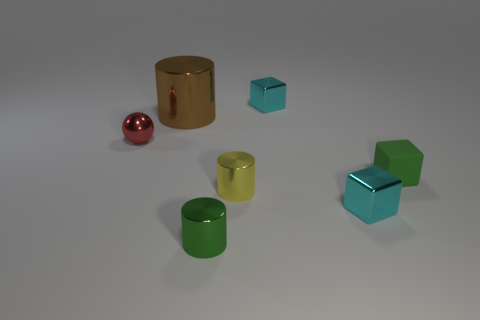Are there any other things that have the same material as the small green block?
Offer a terse response. No. Is there anything else that has the same size as the brown metallic object?
Offer a terse response. No. There is a matte object; does it have the same color as the small cylinder to the left of the tiny yellow cylinder?
Offer a very short reply. Yes. Are there an equal number of tiny yellow metal objects in front of the tiny green metallic cylinder and tiny spheres?
Give a very brief answer. No. What number of rubber blocks have the same size as the brown object?
Ensure brevity in your answer.  0. There is a thing that is the same color as the matte block; what shape is it?
Make the answer very short. Cylinder. Are any shiny cylinders visible?
Your answer should be compact. Yes. Do the brown thing behind the red thing and the cyan shiny thing that is in front of the green rubber object have the same shape?
Offer a very short reply. No. What number of small things are balls or yellow metal cylinders?
Offer a terse response. 2. What shape is the large brown thing that is made of the same material as the small red object?
Ensure brevity in your answer.  Cylinder. 